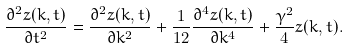Convert formula to latex. <formula><loc_0><loc_0><loc_500><loc_500>\frac { \partial ^ { 2 } z ( k , t ) } { \partial t ^ { 2 } } = \frac { \partial ^ { 2 } z ( k , t ) } { \partial k ^ { 2 } } + \frac { 1 } { 1 2 } \frac { \partial ^ { 4 } z ( k , t ) } { \partial k ^ { 4 } } + \frac { \gamma ^ { 2 } } { 4 } z ( k , t ) .</formula> 